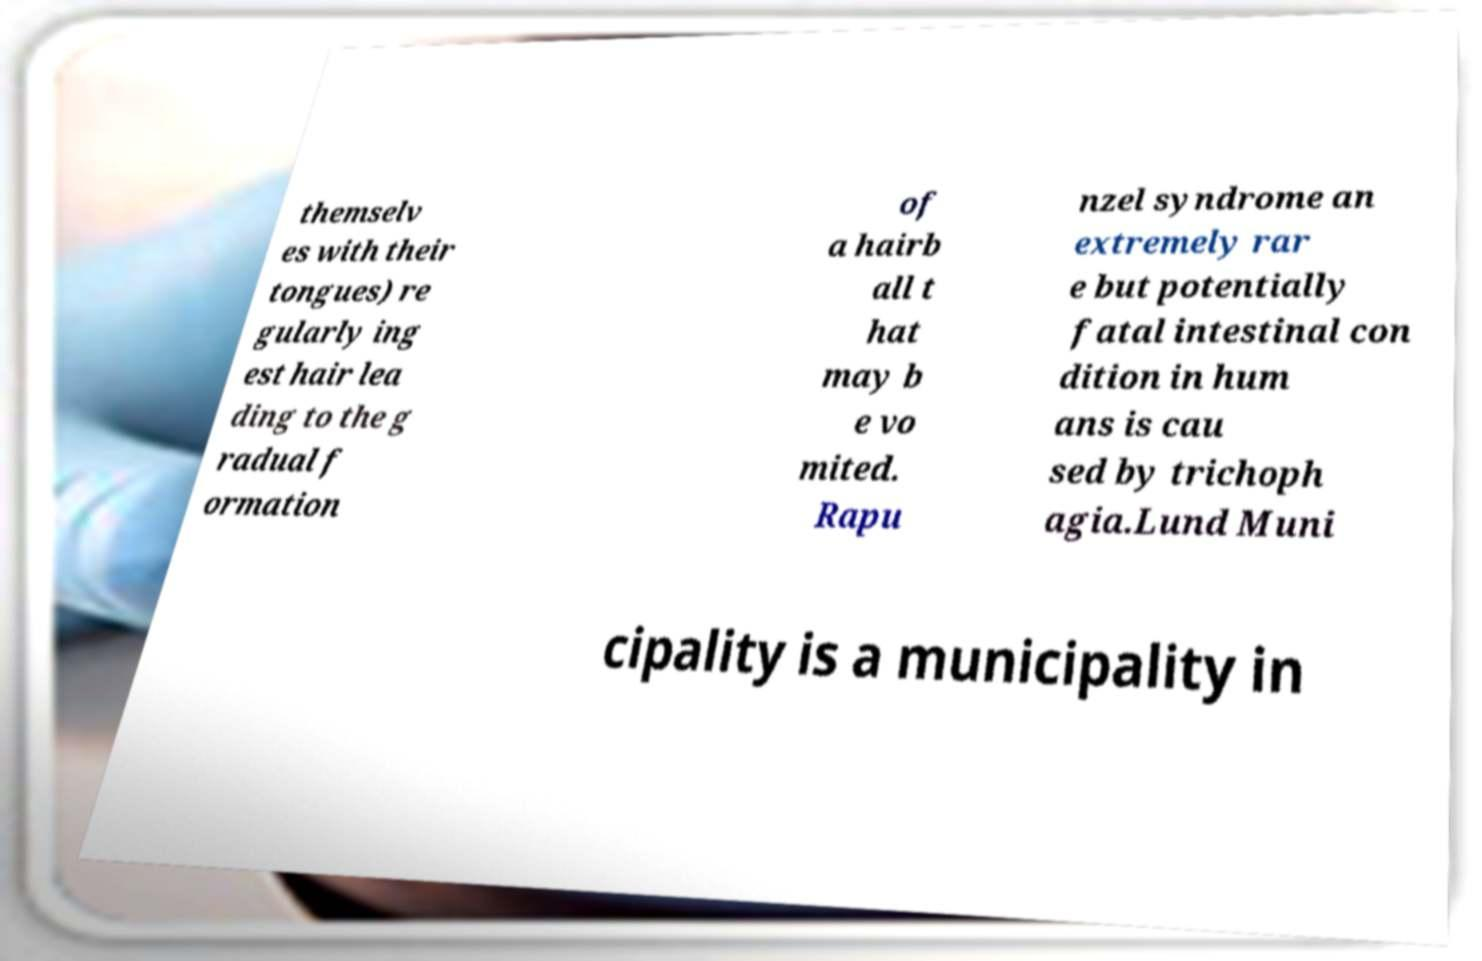For documentation purposes, I need the text within this image transcribed. Could you provide that? themselv es with their tongues) re gularly ing est hair lea ding to the g radual f ormation of a hairb all t hat may b e vo mited. Rapu nzel syndrome an extremely rar e but potentially fatal intestinal con dition in hum ans is cau sed by trichoph agia.Lund Muni cipality is a municipality in 